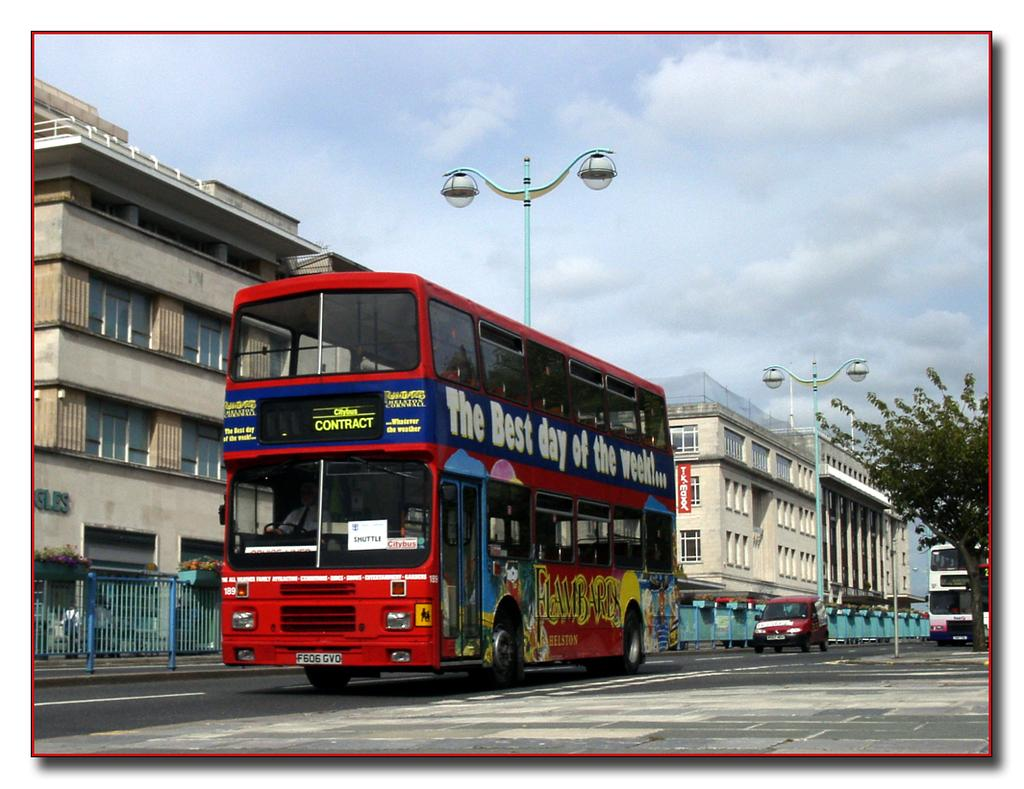How many double-decker buses are on the road in the image? There are two double-decker buses on the road in the image. What other type of vehicle is present in the image? There is a car in the image. What structures can be seen in the background of the image? There are buildings visible in the image. What type of street infrastructure is present in the image? Street light poles are present in the image. What type of barrier is visible in the image? There is a fencing in the image. What type of natural elements are visible in the image? Trees are visible in the image. What part of the natural environment is visible in the image? The sky is visible in the image. What type of pollution is visible in the image? There is no visible pollution in the image. Where is the desk located in the image? There is no desk present in the image. 